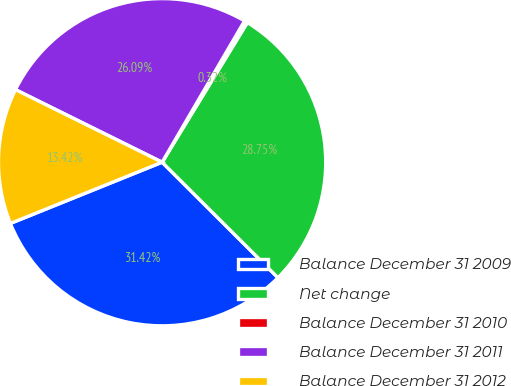Convert chart to OTSL. <chart><loc_0><loc_0><loc_500><loc_500><pie_chart><fcel>Balance December 31 2009<fcel>Net change<fcel>Balance December 31 2010<fcel>Balance December 31 2011<fcel>Balance December 31 2012<nl><fcel>31.42%<fcel>28.75%<fcel>0.32%<fcel>26.09%<fcel>13.42%<nl></chart> 